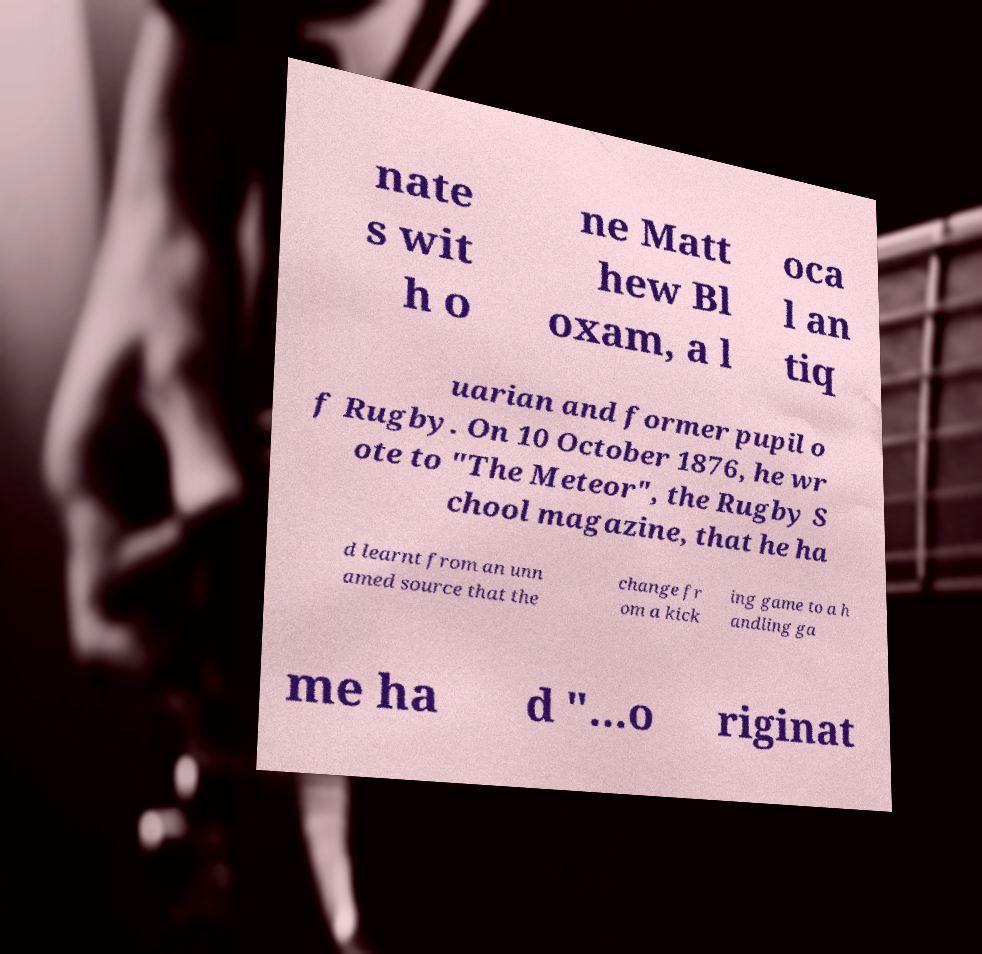What messages or text are displayed in this image? I need them in a readable, typed format. nate s wit h o ne Matt hew Bl oxam, a l oca l an tiq uarian and former pupil o f Rugby. On 10 October 1876, he wr ote to "The Meteor", the Rugby S chool magazine, that he ha d learnt from an unn amed source that the change fr om a kick ing game to a h andling ga me ha d "...o riginat 